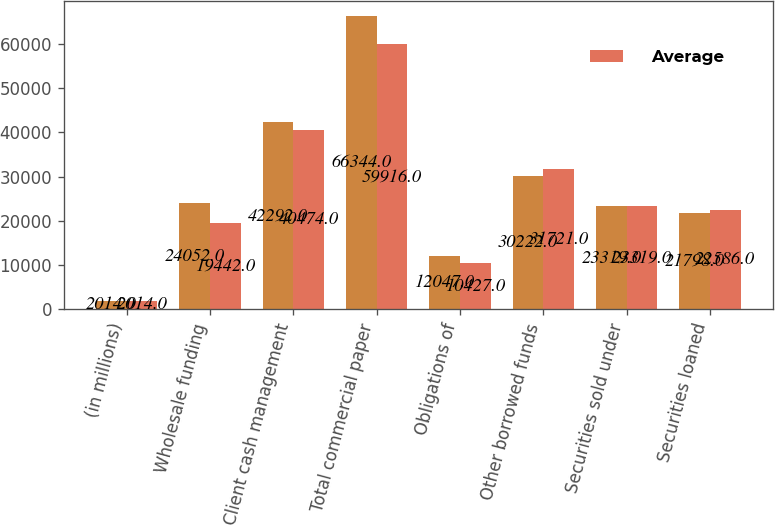Convert chart. <chart><loc_0><loc_0><loc_500><loc_500><stacked_bar_chart><ecel><fcel>(in millions)<fcel>Wholesale funding<fcel>Client cash management<fcel>Total commercial paper<fcel>Obligations of<fcel>Other borrowed funds<fcel>Securities sold under<fcel>Securities loaned<nl><fcel>nan<fcel>2014<fcel>24052<fcel>42292<fcel>66344<fcel>12047<fcel>30222<fcel>23319<fcel>21798<nl><fcel>Average<fcel>2014<fcel>19442<fcel>40474<fcel>59916<fcel>10427<fcel>31721<fcel>23319<fcel>22586<nl></chart> 